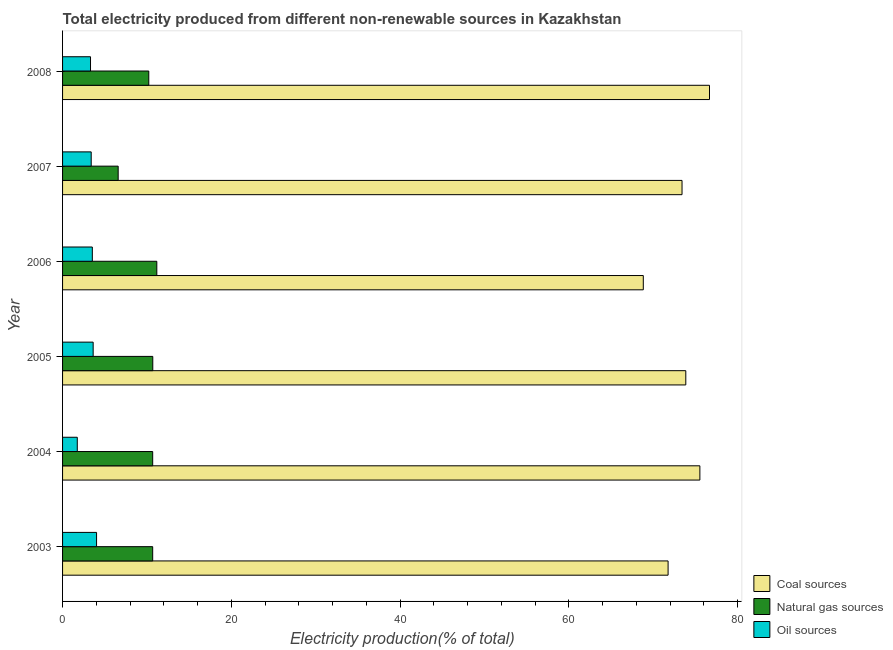What is the percentage of electricity produced by natural gas in 2004?
Ensure brevity in your answer.  10.68. Across all years, what is the maximum percentage of electricity produced by natural gas?
Provide a succinct answer. 11.17. Across all years, what is the minimum percentage of electricity produced by coal?
Provide a succinct answer. 68.82. In which year was the percentage of electricity produced by coal maximum?
Offer a very short reply. 2008. What is the total percentage of electricity produced by natural gas in the graph?
Provide a short and direct response. 60.02. What is the difference between the percentage of electricity produced by natural gas in 2004 and that in 2006?
Ensure brevity in your answer.  -0.49. What is the difference between the percentage of electricity produced by coal in 2007 and the percentage of electricity produced by oil sources in 2005?
Make the answer very short. 69.78. What is the average percentage of electricity produced by oil sources per year?
Make the answer very short. 3.27. In the year 2006, what is the difference between the percentage of electricity produced by natural gas and percentage of electricity produced by oil sources?
Provide a succinct answer. 7.64. In how many years, is the percentage of electricity produced by natural gas greater than 16 %?
Offer a very short reply. 0. What is the ratio of the percentage of electricity produced by coal in 2003 to that in 2008?
Make the answer very short. 0.94. Is the percentage of electricity produced by oil sources in 2006 less than that in 2008?
Your response must be concise. No. What is the difference between the highest and the second highest percentage of electricity produced by natural gas?
Your answer should be compact. 0.48. What is the difference between the highest and the lowest percentage of electricity produced by coal?
Your answer should be compact. 7.84. What does the 2nd bar from the top in 2007 represents?
Your response must be concise. Natural gas sources. What does the 3rd bar from the bottom in 2007 represents?
Your answer should be very brief. Oil sources. Is it the case that in every year, the sum of the percentage of electricity produced by coal and percentage of electricity produced by natural gas is greater than the percentage of electricity produced by oil sources?
Keep it short and to the point. Yes. How many years are there in the graph?
Your response must be concise. 6. What is the title of the graph?
Make the answer very short. Total electricity produced from different non-renewable sources in Kazakhstan. What is the Electricity production(% of total) in Coal sources in 2003?
Provide a succinct answer. 71.75. What is the Electricity production(% of total) of Natural gas sources in 2003?
Make the answer very short. 10.68. What is the Electricity production(% of total) of Oil sources in 2003?
Offer a very short reply. 4.03. What is the Electricity production(% of total) in Coal sources in 2004?
Offer a terse response. 75.52. What is the Electricity production(% of total) of Natural gas sources in 2004?
Your response must be concise. 10.68. What is the Electricity production(% of total) of Oil sources in 2004?
Offer a terse response. 1.74. What is the Electricity production(% of total) of Coal sources in 2005?
Your response must be concise. 73.85. What is the Electricity production(% of total) of Natural gas sources in 2005?
Keep it short and to the point. 10.69. What is the Electricity production(% of total) of Oil sources in 2005?
Provide a succinct answer. 3.63. What is the Electricity production(% of total) of Coal sources in 2006?
Give a very brief answer. 68.82. What is the Electricity production(% of total) of Natural gas sources in 2006?
Your response must be concise. 11.17. What is the Electricity production(% of total) in Oil sources in 2006?
Provide a short and direct response. 3.53. What is the Electricity production(% of total) in Coal sources in 2007?
Provide a succinct answer. 73.41. What is the Electricity production(% of total) in Natural gas sources in 2007?
Make the answer very short. 6.59. What is the Electricity production(% of total) in Oil sources in 2007?
Your answer should be compact. 3.39. What is the Electricity production(% of total) in Coal sources in 2008?
Make the answer very short. 76.66. What is the Electricity production(% of total) of Natural gas sources in 2008?
Your response must be concise. 10.22. What is the Electricity production(% of total) in Oil sources in 2008?
Make the answer very short. 3.31. Across all years, what is the maximum Electricity production(% of total) of Coal sources?
Offer a terse response. 76.66. Across all years, what is the maximum Electricity production(% of total) in Natural gas sources?
Keep it short and to the point. 11.17. Across all years, what is the maximum Electricity production(% of total) of Oil sources?
Make the answer very short. 4.03. Across all years, what is the minimum Electricity production(% of total) of Coal sources?
Your response must be concise. 68.82. Across all years, what is the minimum Electricity production(% of total) of Natural gas sources?
Your response must be concise. 6.59. Across all years, what is the minimum Electricity production(% of total) of Oil sources?
Make the answer very short. 1.74. What is the total Electricity production(% of total) in Coal sources in the graph?
Offer a very short reply. 440.02. What is the total Electricity production(% of total) of Natural gas sources in the graph?
Ensure brevity in your answer.  60.02. What is the total Electricity production(% of total) in Oil sources in the graph?
Provide a succinct answer. 19.63. What is the difference between the Electricity production(% of total) of Coal sources in 2003 and that in 2004?
Provide a succinct answer. -3.77. What is the difference between the Electricity production(% of total) in Natural gas sources in 2003 and that in 2004?
Your answer should be very brief. -0. What is the difference between the Electricity production(% of total) in Oil sources in 2003 and that in 2004?
Offer a terse response. 2.29. What is the difference between the Electricity production(% of total) in Coal sources in 2003 and that in 2005?
Your response must be concise. -2.1. What is the difference between the Electricity production(% of total) of Natural gas sources in 2003 and that in 2005?
Provide a succinct answer. -0.01. What is the difference between the Electricity production(% of total) of Oil sources in 2003 and that in 2005?
Keep it short and to the point. 0.4. What is the difference between the Electricity production(% of total) in Coal sources in 2003 and that in 2006?
Keep it short and to the point. 2.94. What is the difference between the Electricity production(% of total) in Natural gas sources in 2003 and that in 2006?
Your answer should be compact. -0.49. What is the difference between the Electricity production(% of total) in Oil sources in 2003 and that in 2006?
Ensure brevity in your answer.  0.5. What is the difference between the Electricity production(% of total) of Coal sources in 2003 and that in 2007?
Provide a succinct answer. -1.65. What is the difference between the Electricity production(% of total) of Natural gas sources in 2003 and that in 2007?
Make the answer very short. 4.09. What is the difference between the Electricity production(% of total) of Oil sources in 2003 and that in 2007?
Provide a short and direct response. 0.63. What is the difference between the Electricity production(% of total) of Coal sources in 2003 and that in 2008?
Your answer should be compact. -4.91. What is the difference between the Electricity production(% of total) in Natural gas sources in 2003 and that in 2008?
Offer a very short reply. 0.46. What is the difference between the Electricity production(% of total) in Oil sources in 2003 and that in 2008?
Your answer should be very brief. 0.72. What is the difference between the Electricity production(% of total) in Coal sources in 2004 and that in 2005?
Make the answer very short. 1.67. What is the difference between the Electricity production(% of total) in Natural gas sources in 2004 and that in 2005?
Provide a succinct answer. -0.01. What is the difference between the Electricity production(% of total) in Oil sources in 2004 and that in 2005?
Give a very brief answer. -1.88. What is the difference between the Electricity production(% of total) of Coal sources in 2004 and that in 2006?
Provide a short and direct response. 6.7. What is the difference between the Electricity production(% of total) in Natural gas sources in 2004 and that in 2006?
Keep it short and to the point. -0.49. What is the difference between the Electricity production(% of total) in Oil sources in 2004 and that in 2006?
Your answer should be very brief. -1.78. What is the difference between the Electricity production(% of total) in Coal sources in 2004 and that in 2007?
Ensure brevity in your answer.  2.12. What is the difference between the Electricity production(% of total) of Natural gas sources in 2004 and that in 2007?
Your answer should be very brief. 4.09. What is the difference between the Electricity production(% of total) of Oil sources in 2004 and that in 2007?
Offer a terse response. -1.65. What is the difference between the Electricity production(% of total) in Coal sources in 2004 and that in 2008?
Your answer should be compact. -1.14. What is the difference between the Electricity production(% of total) of Natural gas sources in 2004 and that in 2008?
Offer a terse response. 0.46. What is the difference between the Electricity production(% of total) of Oil sources in 2004 and that in 2008?
Offer a terse response. -1.57. What is the difference between the Electricity production(% of total) of Coal sources in 2005 and that in 2006?
Provide a short and direct response. 5.03. What is the difference between the Electricity production(% of total) in Natural gas sources in 2005 and that in 2006?
Provide a succinct answer. -0.48. What is the difference between the Electricity production(% of total) of Oil sources in 2005 and that in 2006?
Keep it short and to the point. 0.1. What is the difference between the Electricity production(% of total) in Coal sources in 2005 and that in 2007?
Make the answer very short. 0.45. What is the difference between the Electricity production(% of total) in Natural gas sources in 2005 and that in 2007?
Provide a succinct answer. 4.1. What is the difference between the Electricity production(% of total) in Oil sources in 2005 and that in 2007?
Provide a short and direct response. 0.23. What is the difference between the Electricity production(% of total) in Coal sources in 2005 and that in 2008?
Make the answer very short. -2.81. What is the difference between the Electricity production(% of total) of Natural gas sources in 2005 and that in 2008?
Offer a very short reply. 0.47. What is the difference between the Electricity production(% of total) of Oil sources in 2005 and that in 2008?
Ensure brevity in your answer.  0.31. What is the difference between the Electricity production(% of total) of Coal sources in 2006 and that in 2007?
Provide a succinct answer. -4.59. What is the difference between the Electricity production(% of total) in Natural gas sources in 2006 and that in 2007?
Offer a terse response. 4.58. What is the difference between the Electricity production(% of total) in Oil sources in 2006 and that in 2007?
Keep it short and to the point. 0.13. What is the difference between the Electricity production(% of total) in Coal sources in 2006 and that in 2008?
Give a very brief answer. -7.84. What is the difference between the Electricity production(% of total) of Natural gas sources in 2006 and that in 2008?
Provide a succinct answer. 0.95. What is the difference between the Electricity production(% of total) of Oil sources in 2006 and that in 2008?
Offer a very short reply. 0.22. What is the difference between the Electricity production(% of total) in Coal sources in 2007 and that in 2008?
Your answer should be compact. -3.26. What is the difference between the Electricity production(% of total) in Natural gas sources in 2007 and that in 2008?
Keep it short and to the point. -3.63. What is the difference between the Electricity production(% of total) in Oil sources in 2007 and that in 2008?
Provide a short and direct response. 0.08. What is the difference between the Electricity production(% of total) of Coal sources in 2003 and the Electricity production(% of total) of Natural gas sources in 2004?
Your response must be concise. 61.08. What is the difference between the Electricity production(% of total) in Coal sources in 2003 and the Electricity production(% of total) in Oil sources in 2004?
Your answer should be compact. 70.01. What is the difference between the Electricity production(% of total) in Natural gas sources in 2003 and the Electricity production(% of total) in Oil sources in 2004?
Provide a short and direct response. 8.94. What is the difference between the Electricity production(% of total) in Coal sources in 2003 and the Electricity production(% of total) in Natural gas sources in 2005?
Your response must be concise. 61.06. What is the difference between the Electricity production(% of total) of Coal sources in 2003 and the Electricity production(% of total) of Oil sources in 2005?
Provide a short and direct response. 68.13. What is the difference between the Electricity production(% of total) of Natural gas sources in 2003 and the Electricity production(% of total) of Oil sources in 2005?
Provide a succinct answer. 7.05. What is the difference between the Electricity production(% of total) in Coal sources in 2003 and the Electricity production(% of total) in Natural gas sources in 2006?
Your answer should be very brief. 60.59. What is the difference between the Electricity production(% of total) in Coal sources in 2003 and the Electricity production(% of total) in Oil sources in 2006?
Provide a succinct answer. 68.23. What is the difference between the Electricity production(% of total) in Natural gas sources in 2003 and the Electricity production(% of total) in Oil sources in 2006?
Make the answer very short. 7.15. What is the difference between the Electricity production(% of total) in Coal sources in 2003 and the Electricity production(% of total) in Natural gas sources in 2007?
Make the answer very short. 65.16. What is the difference between the Electricity production(% of total) in Coal sources in 2003 and the Electricity production(% of total) in Oil sources in 2007?
Provide a short and direct response. 68.36. What is the difference between the Electricity production(% of total) of Natural gas sources in 2003 and the Electricity production(% of total) of Oil sources in 2007?
Give a very brief answer. 7.28. What is the difference between the Electricity production(% of total) in Coal sources in 2003 and the Electricity production(% of total) in Natural gas sources in 2008?
Ensure brevity in your answer.  61.54. What is the difference between the Electricity production(% of total) of Coal sources in 2003 and the Electricity production(% of total) of Oil sources in 2008?
Ensure brevity in your answer.  68.44. What is the difference between the Electricity production(% of total) in Natural gas sources in 2003 and the Electricity production(% of total) in Oil sources in 2008?
Keep it short and to the point. 7.37. What is the difference between the Electricity production(% of total) in Coal sources in 2004 and the Electricity production(% of total) in Natural gas sources in 2005?
Offer a very short reply. 64.83. What is the difference between the Electricity production(% of total) in Coal sources in 2004 and the Electricity production(% of total) in Oil sources in 2005?
Keep it short and to the point. 71.9. What is the difference between the Electricity production(% of total) of Natural gas sources in 2004 and the Electricity production(% of total) of Oil sources in 2005?
Provide a succinct answer. 7.05. What is the difference between the Electricity production(% of total) of Coal sources in 2004 and the Electricity production(% of total) of Natural gas sources in 2006?
Give a very brief answer. 64.35. What is the difference between the Electricity production(% of total) of Coal sources in 2004 and the Electricity production(% of total) of Oil sources in 2006?
Keep it short and to the point. 72. What is the difference between the Electricity production(% of total) in Natural gas sources in 2004 and the Electricity production(% of total) in Oil sources in 2006?
Provide a short and direct response. 7.15. What is the difference between the Electricity production(% of total) in Coal sources in 2004 and the Electricity production(% of total) in Natural gas sources in 2007?
Your answer should be compact. 68.93. What is the difference between the Electricity production(% of total) in Coal sources in 2004 and the Electricity production(% of total) in Oil sources in 2007?
Offer a very short reply. 72.13. What is the difference between the Electricity production(% of total) in Natural gas sources in 2004 and the Electricity production(% of total) in Oil sources in 2007?
Offer a terse response. 7.28. What is the difference between the Electricity production(% of total) of Coal sources in 2004 and the Electricity production(% of total) of Natural gas sources in 2008?
Offer a terse response. 65.31. What is the difference between the Electricity production(% of total) of Coal sources in 2004 and the Electricity production(% of total) of Oil sources in 2008?
Offer a very short reply. 72.21. What is the difference between the Electricity production(% of total) in Natural gas sources in 2004 and the Electricity production(% of total) in Oil sources in 2008?
Your answer should be compact. 7.37. What is the difference between the Electricity production(% of total) in Coal sources in 2005 and the Electricity production(% of total) in Natural gas sources in 2006?
Offer a terse response. 62.68. What is the difference between the Electricity production(% of total) in Coal sources in 2005 and the Electricity production(% of total) in Oil sources in 2006?
Offer a terse response. 70.33. What is the difference between the Electricity production(% of total) in Natural gas sources in 2005 and the Electricity production(% of total) in Oil sources in 2006?
Your response must be concise. 7.16. What is the difference between the Electricity production(% of total) in Coal sources in 2005 and the Electricity production(% of total) in Natural gas sources in 2007?
Offer a very short reply. 67.26. What is the difference between the Electricity production(% of total) in Coal sources in 2005 and the Electricity production(% of total) in Oil sources in 2007?
Your answer should be compact. 70.46. What is the difference between the Electricity production(% of total) of Natural gas sources in 2005 and the Electricity production(% of total) of Oil sources in 2007?
Ensure brevity in your answer.  7.3. What is the difference between the Electricity production(% of total) in Coal sources in 2005 and the Electricity production(% of total) in Natural gas sources in 2008?
Your answer should be very brief. 63.64. What is the difference between the Electricity production(% of total) of Coal sources in 2005 and the Electricity production(% of total) of Oil sources in 2008?
Offer a terse response. 70.54. What is the difference between the Electricity production(% of total) of Natural gas sources in 2005 and the Electricity production(% of total) of Oil sources in 2008?
Your answer should be compact. 7.38. What is the difference between the Electricity production(% of total) of Coal sources in 2006 and the Electricity production(% of total) of Natural gas sources in 2007?
Give a very brief answer. 62.23. What is the difference between the Electricity production(% of total) in Coal sources in 2006 and the Electricity production(% of total) in Oil sources in 2007?
Keep it short and to the point. 65.42. What is the difference between the Electricity production(% of total) of Natural gas sources in 2006 and the Electricity production(% of total) of Oil sources in 2007?
Keep it short and to the point. 7.77. What is the difference between the Electricity production(% of total) of Coal sources in 2006 and the Electricity production(% of total) of Natural gas sources in 2008?
Your answer should be compact. 58.6. What is the difference between the Electricity production(% of total) of Coal sources in 2006 and the Electricity production(% of total) of Oil sources in 2008?
Offer a very short reply. 65.51. What is the difference between the Electricity production(% of total) in Natural gas sources in 2006 and the Electricity production(% of total) in Oil sources in 2008?
Provide a succinct answer. 7.86. What is the difference between the Electricity production(% of total) of Coal sources in 2007 and the Electricity production(% of total) of Natural gas sources in 2008?
Your answer should be very brief. 63.19. What is the difference between the Electricity production(% of total) in Coal sources in 2007 and the Electricity production(% of total) in Oil sources in 2008?
Provide a short and direct response. 70.1. What is the difference between the Electricity production(% of total) of Natural gas sources in 2007 and the Electricity production(% of total) of Oil sources in 2008?
Offer a very short reply. 3.28. What is the average Electricity production(% of total) of Coal sources per year?
Give a very brief answer. 73.34. What is the average Electricity production(% of total) in Natural gas sources per year?
Your response must be concise. 10. What is the average Electricity production(% of total) in Oil sources per year?
Your answer should be compact. 3.27. In the year 2003, what is the difference between the Electricity production(% of total) in Coal sources and Electricity production(% of total) in Natural gas sources?
Keep it short and to the point. 61.08. In the year 2003, what is the difference between the Electricity production(% of total) of Coal sources and Electricity production(% of total) of Oil sources?
Provide a succinct answer. 67.73. In the year 2003, what is the difference between the Electricity production(% of total) of Natural gas sources and Electricity production(% of total) of Oil sources?
Your answer should be compact. 6.65. In the year 2004, what is the difference between the Electricity production(% of total) in Coal sources and Electricity production(% of total) in Natural gas sources?
Ensure brevity in your answer.  64.84. In the year 2004, what is the difference between the Electricity production(% of total) in Coal sources and Electricity production(% of total) in Oil sources?
Your response must be concise. 73.78. In the year 2004, what is the difference between the Electricity production(% of total) in Natural gas sources and Electricity production(% of total) in Oil sources?
Your answer should be compact. 8.94. In the year 2005, what is the difference between the Electricity production(% of total) of Coal sources and Electricity production(% of total) of Natural gas sources?
Make the answer very short. 63.16. In the year 2005, what is the difference between the Electricity production(% of total) of Coal sources and Electricity production(% of total) of Oil sources?
Offer a very short reply. 70.23. In the year 2005, what is the difference between the Electricity production(% of total) of Natural gas sources and Electricity production(% of total) of Oil sources?
Your answer should be compact. 7.06. In the year 2006, what is the difference between the Electricity production(% of total) of Coal sources and Electricity production(% of total) of Natural gas sources?
Give a very brief answer. 57.65. In the year 2006, what is the difference between the Electricity production(% of total) of Coal sources and Electricity production(% of total) of Oil sources?
Keep it short and to the point. 65.29. In the year 2006, what is the difference between the Electricity production(% of total) in Natural gas sources and Electricity production(% of total) in Oil sources?
Your answer should be very brief. 7.64. In the year 2007, what is the difference between the Electricity production(% of total) of Coal sources and Electricity production(% of total) of Natural gas sources?
Make the answer very short. 66.82. In the year 2007, what is the difference between the Electricity production(% of total) of Coal sources and Electricity production(% of total) of Oil sources?
Ensure brevity in your answer.  70.01. In the year 2007, what is the difference between the Electricity production(% of total) of Natural gas sources and Electricity production(% of total) of Oil sources?
Give a very brief answer. 3.2. In the year 2008, what is the difference between the Electricity production(% of total) in Coal sources and Electricity production(% of total) in Natural gas sources?
Your answer should be compact. 66.45. In the year 2008, what is the difference between the Electricity production(% of total) of Coal sources and Electricity production(% of total) of Oil sources?
Make the answer very short. 73.35. In the year 2008, what is the difference between the Electricity production(% of total) of Natural gas sources and Electricity production(% of total) of Oil sources?
Keep it short and to the point. 6.9. What is the ratio of the Electricity production(% of total) of Coal sources in 2003 to that in 2004?
Your answer should be compact. 0.95. What is the ratio of the Electricity production(% of total) of Natural gas sources in 2003 to that in 2004?
Your answer should be very brief. 1. What is the ratio of the Electricity production(% of total) in Oil sources in 2003 to that in 2004?
Your answer should be very brief. 2.31. What is the ratio of the Electricity production(% of total) in Coal sources in 2003 to that in 2005?
Make the answer very short. 0.97. What is the ratio of the Electricity production(% of total) in Natural gas sources in 2003 to that in 2005?
Keep it short and to the point. 1. What is the ratio of the Electricity production(% of total) of Oil sources in 2003 to that in 2005?
Provide a succinct answer. 1.11. What is the ratio of the Electricity production(% of total) in Coal sources in 2003 to that in 2006?
Offer a terse response. 1.04. What is the ratio of the Electricity production(% of total) in Natural gas sources in 2003 to that in 2006?
Provide a short and direct response. 0.96. What is the ratio of the Electricity production(% of total) of Oil sources in 2003 to that in 2006?
Provide a succinct answer. 1.14. What is the ratio of the Electricity production(% of total) in Coal sources in 2003 to that in 2007?
Make the answer very short. 0.98. What is the ratio of the Electricity production(% of total) of Natural gas sources in 2003 to that in 2007?
Your response must be concise. 1.62. What is the ratio of the Electricity production(% of total) in Oil sources in 2003 to that in 2007?
Keep it short and to the point. 1.19. What is the ratio of the Electricity production(% of total) of Coal sources in 2003 to that in 2008?
Your answer should be very brief. 0.94. What is the ratio of the Electricity production(% of total) in Natural gas sources in 2003 to that in 2008?
Give a very brief answer. 1.05. What is the ratio of the Electricity production(% of total) of Oil sources in 2003 to that in 2008?
Your response must be concise. 1.22. What is the ratio of the Electricity production(% of total) of Coal sources in 2004 to that in 2005?
Offer a terse response. 1.02. What is the ratio of the Electricity production(% of total) of Oil sources in 2004 to that in 2005?
Offer a terse response. 0.48. What is the ratio of the Electricity production(% of total) of Coal sources in 2004 to that in 2006?
Make the answer very short. 1.1. What is the ratio of the Electricity production(% of total) of Natural gas sources in 2004 to that in 2006?
Make the answer very short. 0.96. What is the ratio of the Electricity production(% of total) of Oil sources in 2004 to that in 2006?
Your answer should be compact. 0.49. What is the ratio of the Electricity production(% of total) in Coal sources in 2004 to that in 2007?
Your answer should be compact. 1.03. What is the ratio of the Electricity production(% of total) in Natural gas sources in 2004 to that in 2007?
Make the answer very short. 1.62. What is the ratio of the Electricity production(% of total) in Oil sources in 2004 to that in 2007?
Provide a short and direct response. 0.51. What is the ratio of the Electricity production(% of total) of Coal sources in 2004 to that in 2008?
Provide a succinct answer. 0.99. What is the ratio of the Electricity production(% of total) of Natural gas sources in 2004 to that in 2008?
Provide a short and direct response. 1.05. What is the ratio of the Electricity production(% of total) of Oil sources in 2004 to that in 2008?
Provide a short and direct response. 0.53. What is the ratio of the Electricity production(% of total) in Coal sources in 2005 to that in 2006?
Keep it short and to the point. 1.07. What is the ratio of the Electricity production(% of total) of Natural gas sources in 2005 to that in 2006?
Offer a very short reply. 0.96. What is the ratio of the Electricity production(% of total) in Oil sources in 2005 to that in 2006?
Offer a terse response. 1.03. What is the ratio of the Electricity production(% of total) of Coal sources in 2005 to that in 2007?
Keep it short and to the point. 1.01. What is the ratio of the Electricity production(% of total) of Natural gas sources in 2005 to that in 2007?
Ensure brevity in your answer.  1.62. What is the ratio of the Electricity production(% of total) of Oil sources in 2005 to that in 2007?
Provide a succinct answer. 1.07. What is the ratio of the Electricity production(% of total) of Coal sources in 2005 to that in 2008?
Offer a terse response. 0.96. What is the ratio of the Electricity production(% of total) of Natural gas sources in 2005 to that in 2008?
Your answer should be compact. 1.05. What is the ratio of the Electricity production(% of total) of Oil sources in 2005 to that in 2008?
Keep it short and to the point. 1.09. What is the ratio of the Electricity production(% of total) of Coal sources in 2006 to that in 2007?
Ensure brevity in your answer.  0.94. What is the ratio of the Electricity production(% of total) of Natural gas sources in 2006 to that in 2007?
Your answer should be very brief. 1.69. What is the ratio of the Electricity production(% of total) of Oil sources in 2006 to that in 2007?
Your response must be concise. 1.04. What is the ratio of the Electricity production(% of total) of Coal sources in 2006 to that in 2008?
Offer a very short reply. 0.9. What is the ratio of the Electricity production(% of total) of Natural gas sources in 2006 to that in 2008?
Provide a succinct answer. 1.09. What is the ratio of the Electricity production(% of total) of Oil sources in 2006 to that in 2008?
Provide a succinct answer. 1.06. What is the ratio of the Electricity production(% of total) in Coal sources in 2007 to that in 2008?
Offer a terse response. 0.96. What is the ratio of the Electricity production(% of total) of Natural gas sources in 2007 to that in 2008?
Keep it short and to the point. 0.65. What is the ratio of the Electricity production(% of total) in Oil sources in 2007 to that in 2008?
Your response must be concise. 1.02. What is the difference between the highest and the second highest Electricity production(% of total) in Coal sources?
Ensure brevity in your answer.  1.14. What is the difference between the highest and the second highest Electricity production(% of total) of Natural gas sources?
Your response must be concise. 0.48. What is the difference between the highest and the second highest Electricity production(% of total) of Oil sources?
Your answer should be compact. 0.4. What is the difference between the highest and the lowest Electricity production(% of total) of Coal sources?
Your response must be concise. 7.84. What is the difference between the highest and the lowest Electricity production(% of total) in Natural gas sources?
Give a very brief answer. 4.58. What is the difference between the highest and the lowest Electricity production(% of total) of Oil sources?
Ensure brevity in your answer.  2.29. 